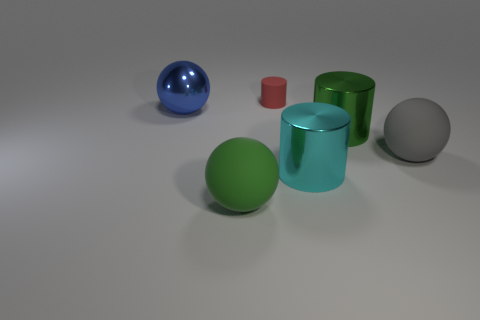There is a matte cylinder; does it have the same color as the large sphere in front of the gray thing?
Offer a terse response. No. Are there the same number of cylinders behind the green metal thing and big green spheres on the left side of the large green ball?
Your answer should be compact. No. What number of other things are there of the same size as the cyan cylinder?
Your answer should be very brief. 4. How big is the red cylinder?
Offer a very short reply. Small. Is the material of the green cylinder the same as the big sphere on the left side of the green matte ball?
Provide a short and direct response. Yes. Is there a gray shiny thing of the same shape as the large cyan metal object?
Your answer should be compact. No. There is a cyan cylinder that is the same size as the blue metallic sphere; what is it made of?
Your response must be concise. Metal. There is a rubber object behind the large blue sphere; what is its size?
Provide a succinct answer. Small. Does the matte sphere to the right of the rubber cylinder have the same size as the metallic cylinder right of the large cyan cylinder?
Offer a very short reply. Yes. What number of red cylinders are made of the same material as the large gray ball?
Provide a short and direct response. 1. 